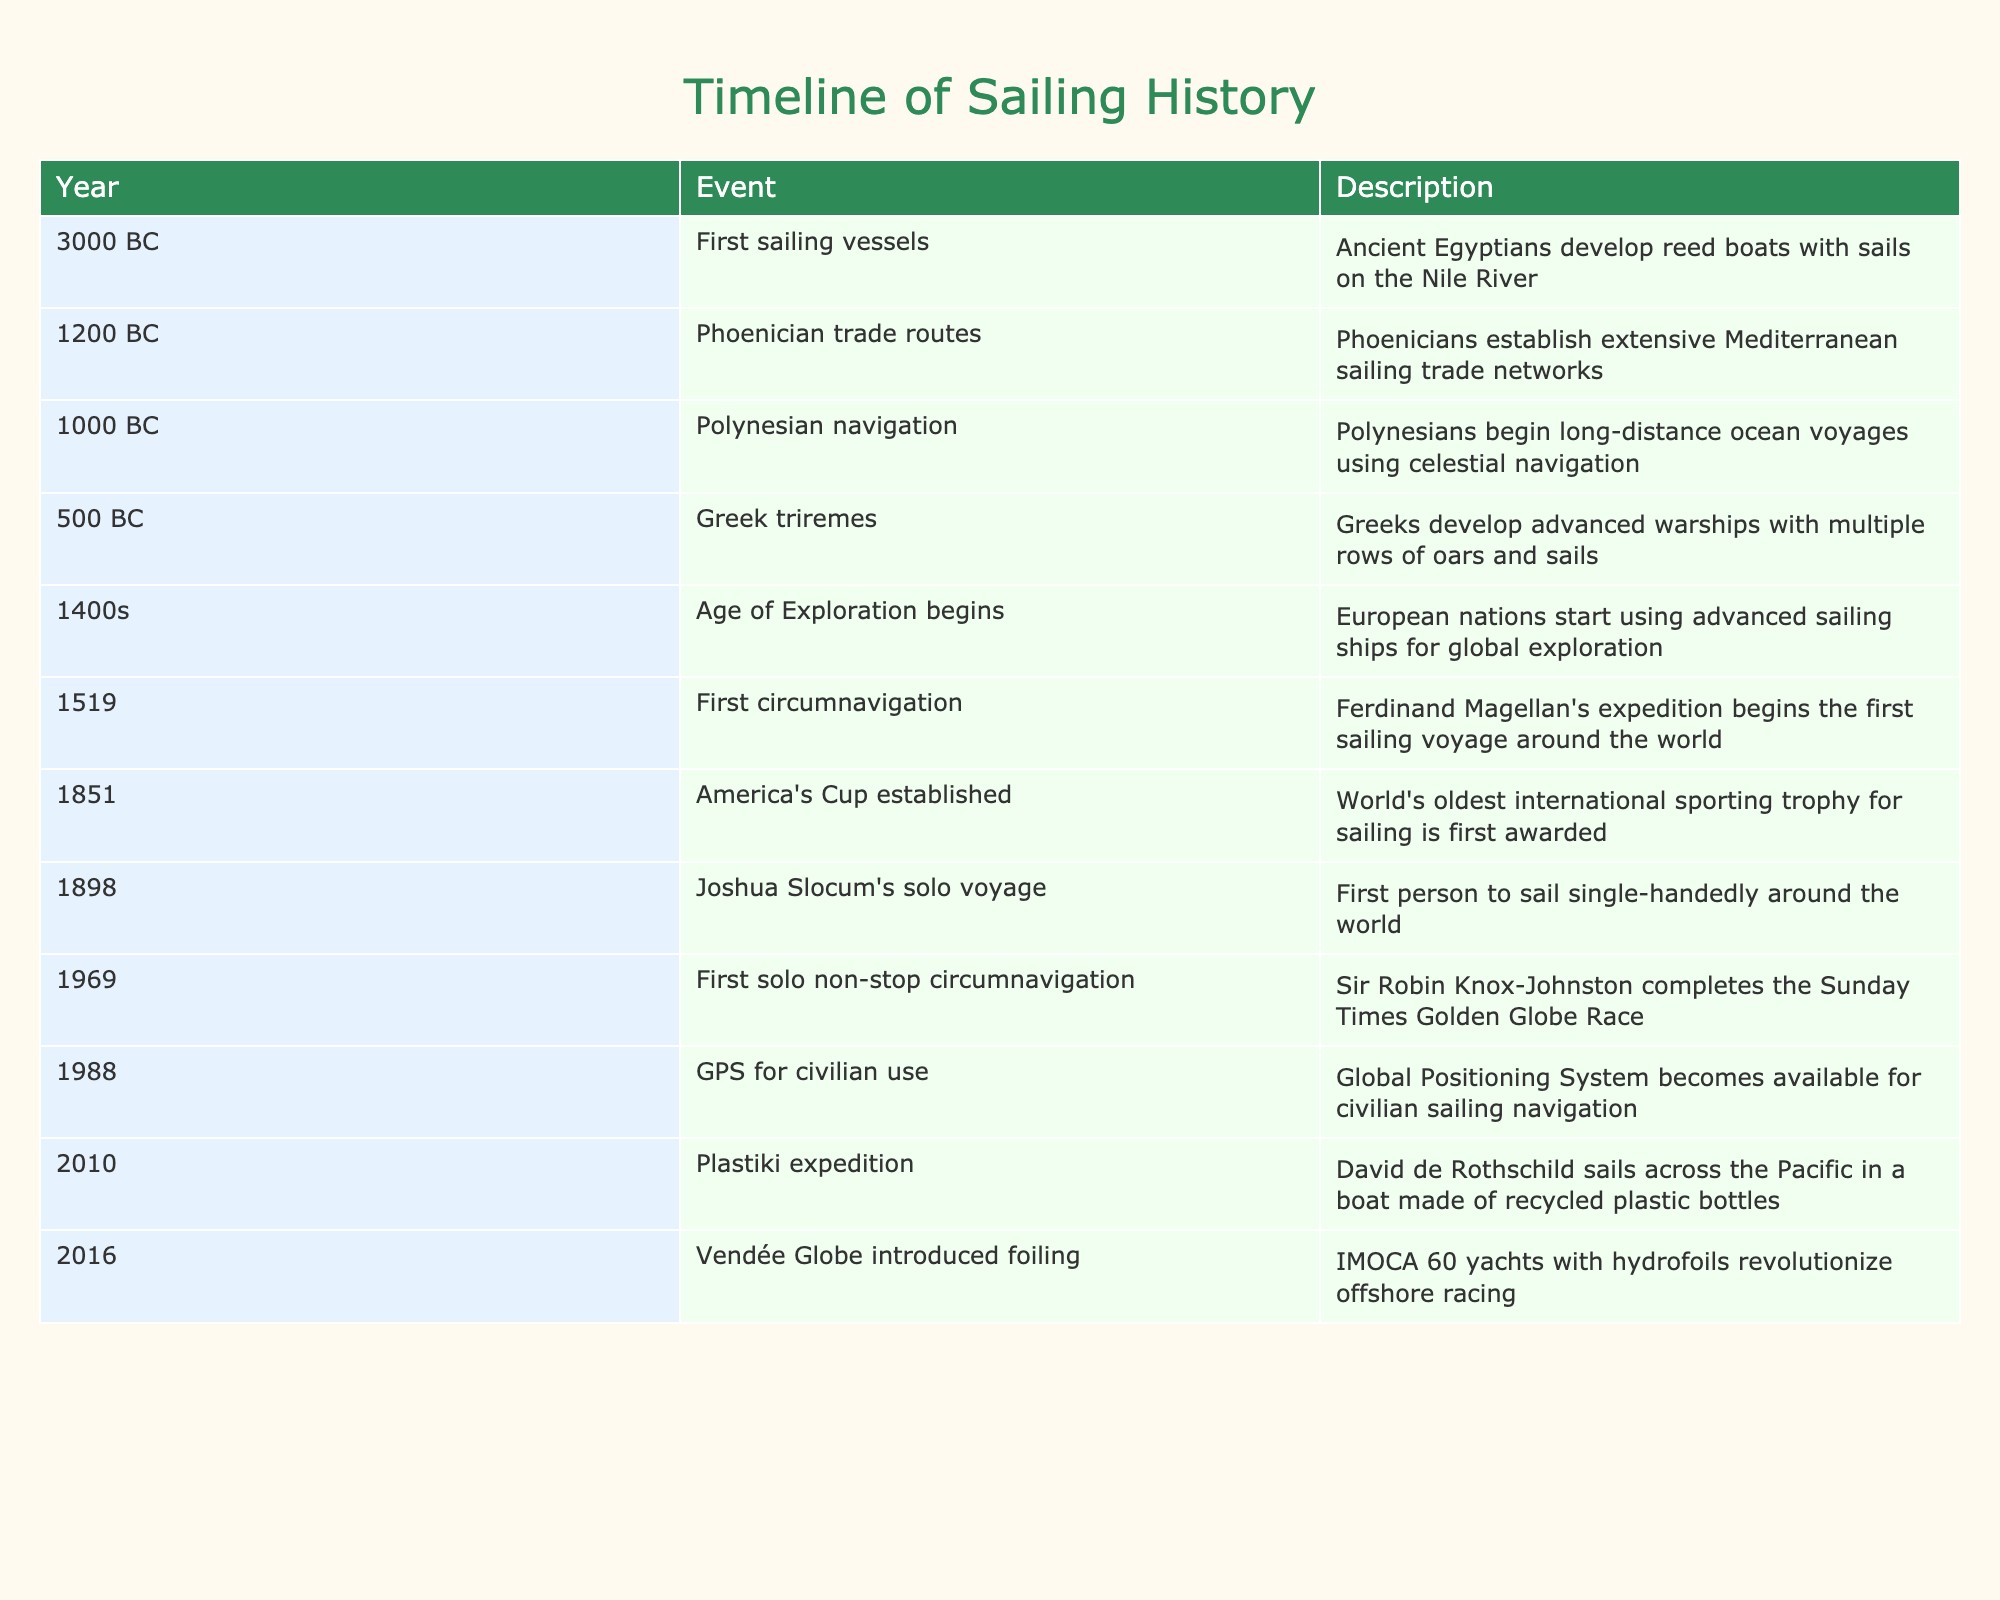What year did the first sailing vessels emerge? According to the table, the event "First sailing vessels" occurred in 3000 BC.
Answer: 3000 BC Which event is noted for being the first circumnavigation of the globe? The table indicates that Ferdinand Magellan's expedition in 1519 marked the first sailing voyage around the world, as specified in the "First circumnavigation" event.
Answer: 1519 True or False: The GPS for civilian use became available before the Plastiki expedition. The table shows that GPS for civilian use was introduced in 1988, while the Plastiki expedition occurred in 2010. Since 1988 is before 2010, this statement is true.
Answer: True How many years apart were the establishment of the America's Cup and the completion of Joshua Slocum's solo voyage? The America's Cup was established in 1851 and Slocum's voyage took place in 1898. To find the difference, subtract: 1898 - 1851 = 47 years.
Answer: 47 years Which two events mark significant advancements in navigation technology? By examining the table, the events "GPS for civilian use" in 1988 and "Vendée Globe introduced foiling" in 2016 represent significant advancements in navigation technology. Both events highlight innovations that enhanced sailing.
Answer: GPS in 1988 and Vendée Globe in 2016 True or False: The Age of Exploration began in the 1400s. The table lists the Age of Exploration as beginning in the 1400s, confirming that this statement is indeed true.
Answer: True What was the primary contribution of the Polynesian navigation? According to the table, the event titled "Polynesian navigation" describes how the Polynesians began long-distance ocean voyages utilizing celestial navigation. This highlights their key contribution to maritime techniques.
Answer: Long-distance ocean voyages using celestial navigation What is the time gap between the first sailing vessels and the development of Greek triremes? The first sailing vessels emerged in 3000 BC and Greek triremes were developed around 500 BC. To determine the gap, compute: 3000 - 500 = 2500 years.
Answer: 2500 years Name the event that first introduced hydrofoils to offshore racing. The table specifies "Vendée Globe introduced foiling" in 2016 as the event that brought hydrofoils into offshore racing, marking a significant innovation in the sport.
Answer: Vendée Globe introduced foiling in 2016 